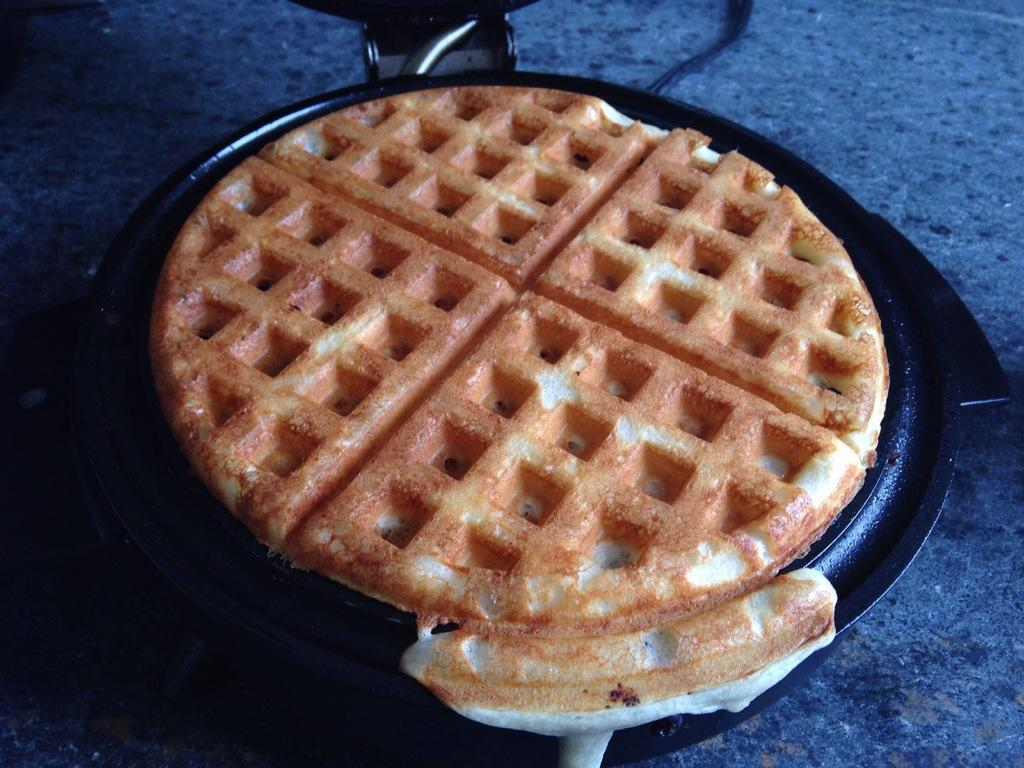What is on the pan that is visible in the image? There is food on a pan in the image. What object can be seen at the bottom of the image? There is a marble at the bottom of the image. What type of material is present in the image? There is a wire in the image. What grade does the marble receive for its performance in the image? The marble is an inanimate object and cannot receive a grade. Is there any paint visible in the image? There is no mention of paint in the provided facts, and therefore it cannot be determined if paint is present in the image. 